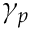<formula> <loc_0><loc_0><loc_500><loc_500>\gamma _ { p }</formula> 